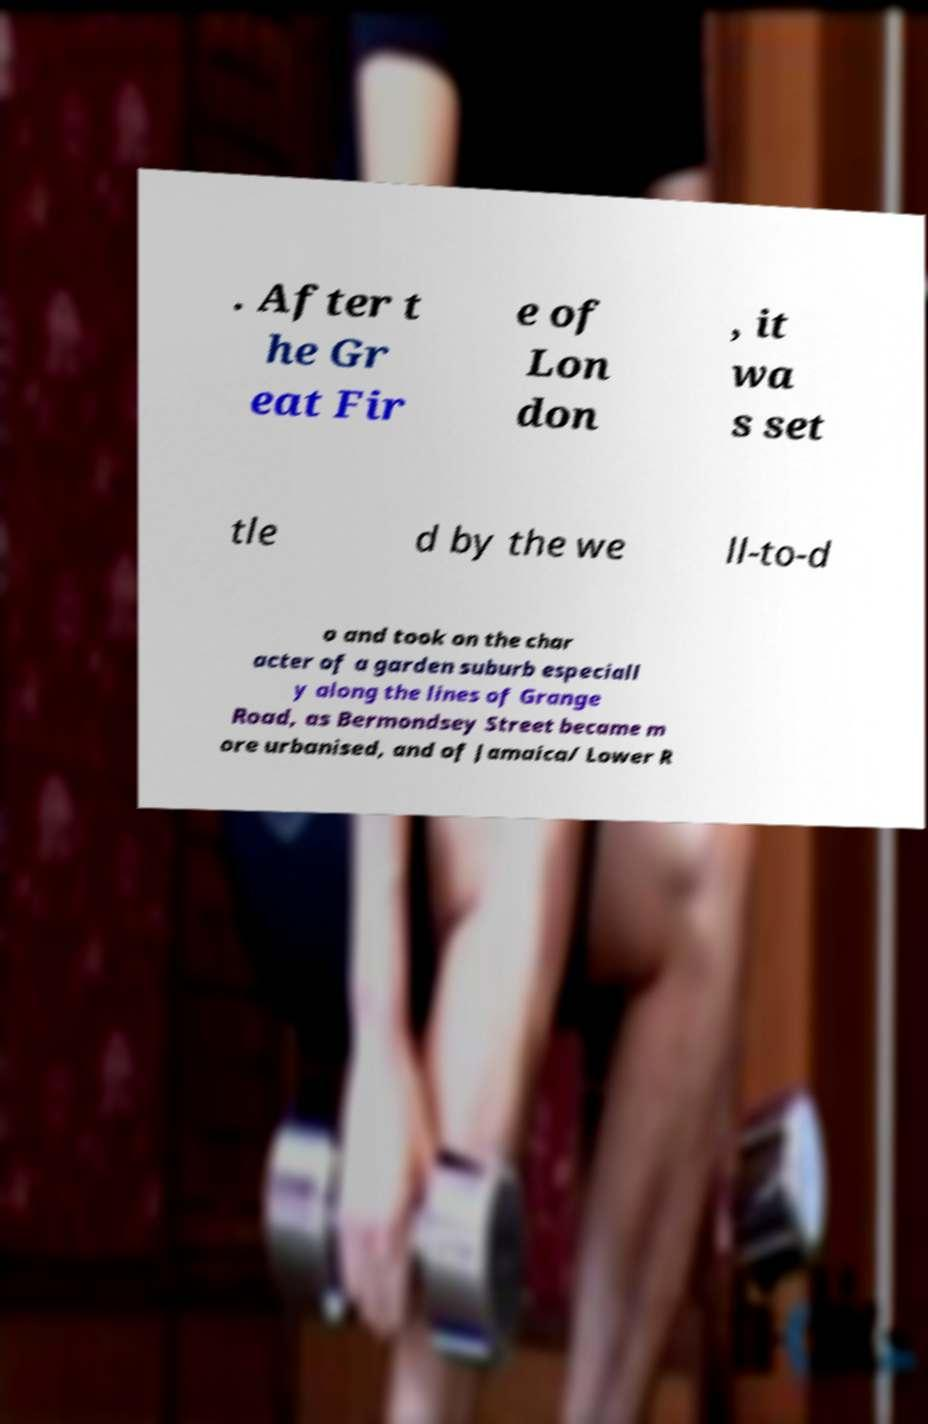For documentation purposes, I need the text within this image transcribed. Could you provide that? . After t he Gr eat Fir e of Lon don , it wa s set tle d by the we ll-to-d o and took on the char acter of a garden suburb especiall y along the lines of Grange Road, as Bermondsey Street became m ore urbanised, and of Jamaica/ Lower R 